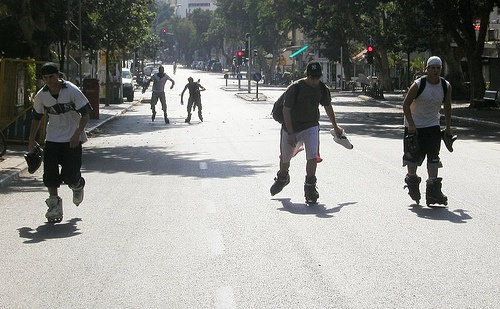Describe the objects in this image and their specific colors. I can see people in black, gray, lightgray, and darkgray tones, people in black, gray, and white tones, people in black, gray, white, and darkgray tones, people in black, gray, white, and darkgray tones, and people in black, gray, darkgray, and lightgray tones in this image. 